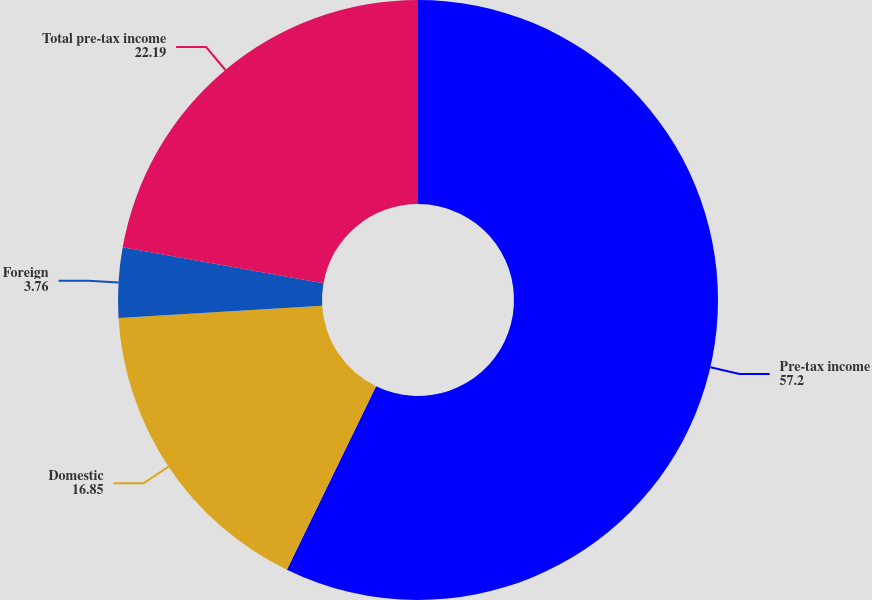Convert chart. <chart><loc_0><loc_0><loc_500><loc_500><pie_chart><fcel>Pre-tax income<fcel>Domestic<fcel>Foreign<fcel>Total pre-tax income<nl><fcel>57.2%<fcel>16.85%<fcel>3.76%<fcel>22.19%<nl></chart> 